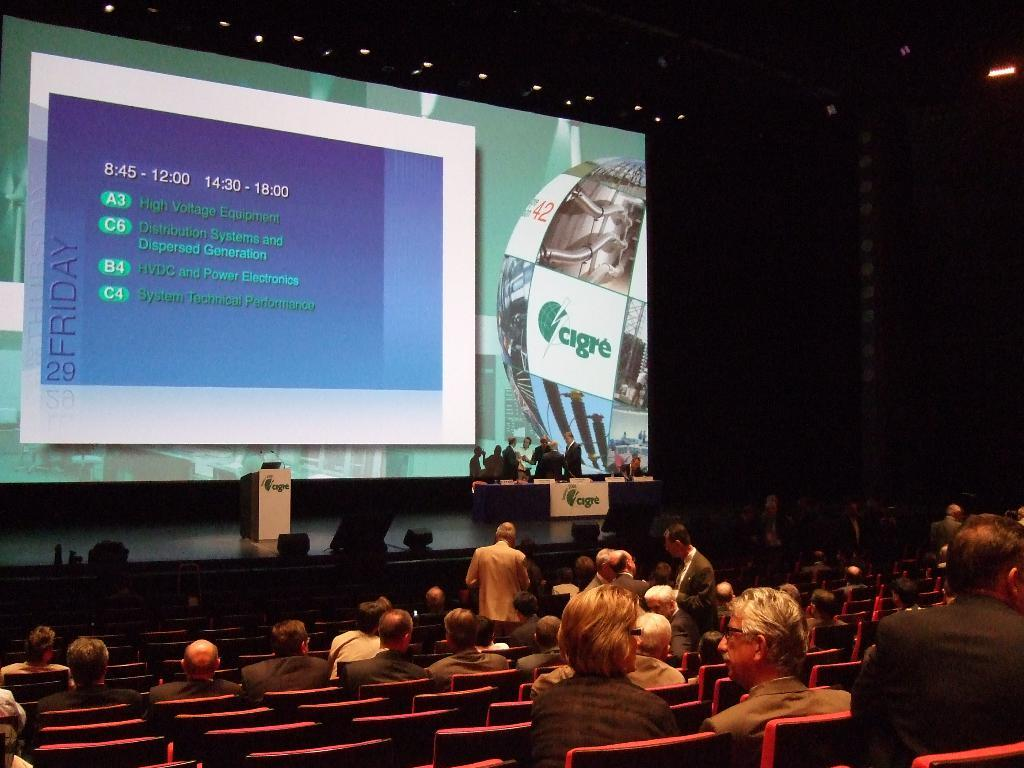<image>
Give a short and clear explanation of the subsequent image. Cigre is the company name shown on the presentation screen. 